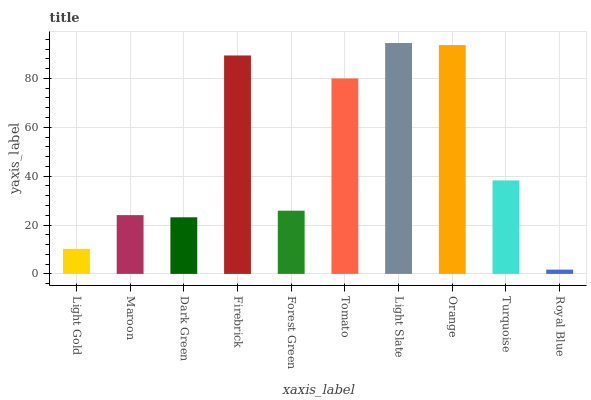Is Maroon the minimum?
Answer yes or no. No. Is Maroon the maximum?
Answer yes or no. No. Is Maroon greater than Light Gold?
Answer yes or no. Yes. Is Light Gold less than Maroon?
Answer yes or no. Yes. Is Light Gold greater than Maroon?
Answer yes or no. No. Is Maroon less than Light Gold?
Answer yes or no. No. Is Turquoise the high median?
Answer yes or no. Yes. Is Forest Green the low median?
Answer yes or no. Yes. Is Forest Green the high median?
Answer yes or no. No. Is Turquoise the low median?
Answer yes or no. No. 